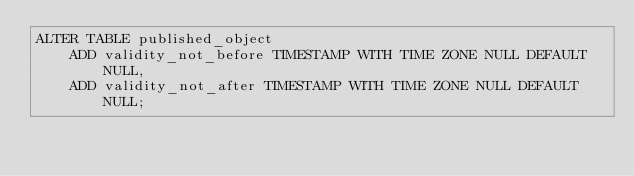<code> <loc_0><loc_0><loc_500><loc_500><_SQL_>ALTER TABLE published_object
    ADD validity_not_before TIMESTAMP WITH TIME ZONE NULL DEFAULT NULL,
    ADD validity_not_after TIMESTAMP WITH TIME ZONE NULL DEFAULT NULL;
</code> 